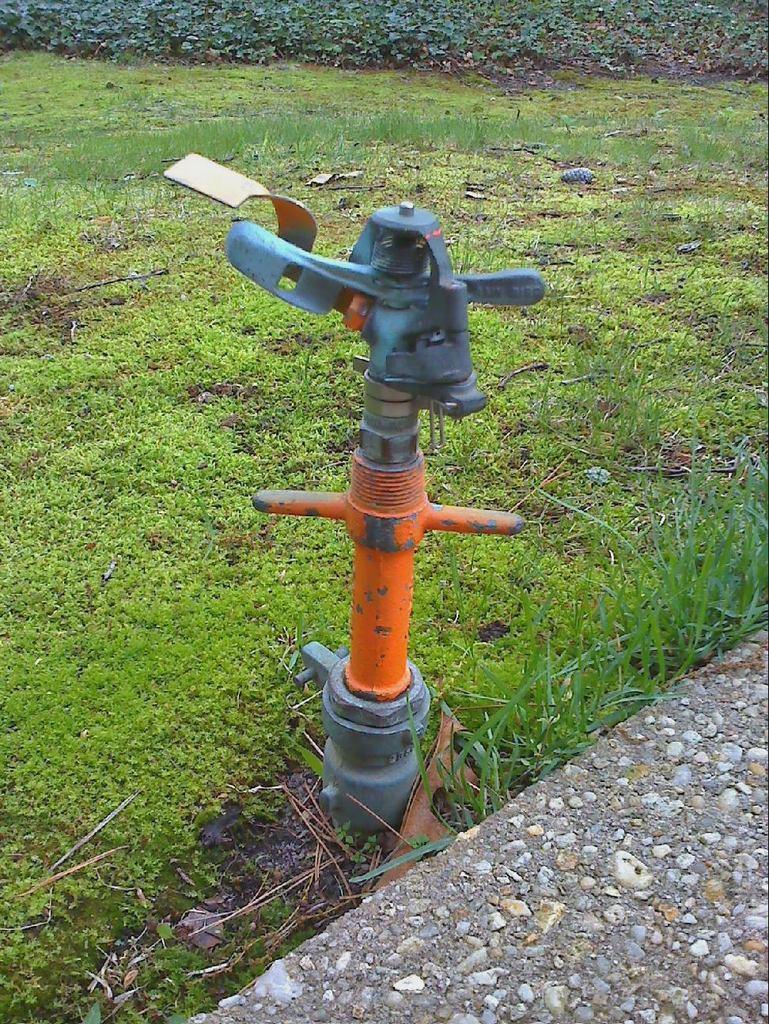Can you describe this image briefly? As we can see in the image there is a water pipe and grass. 